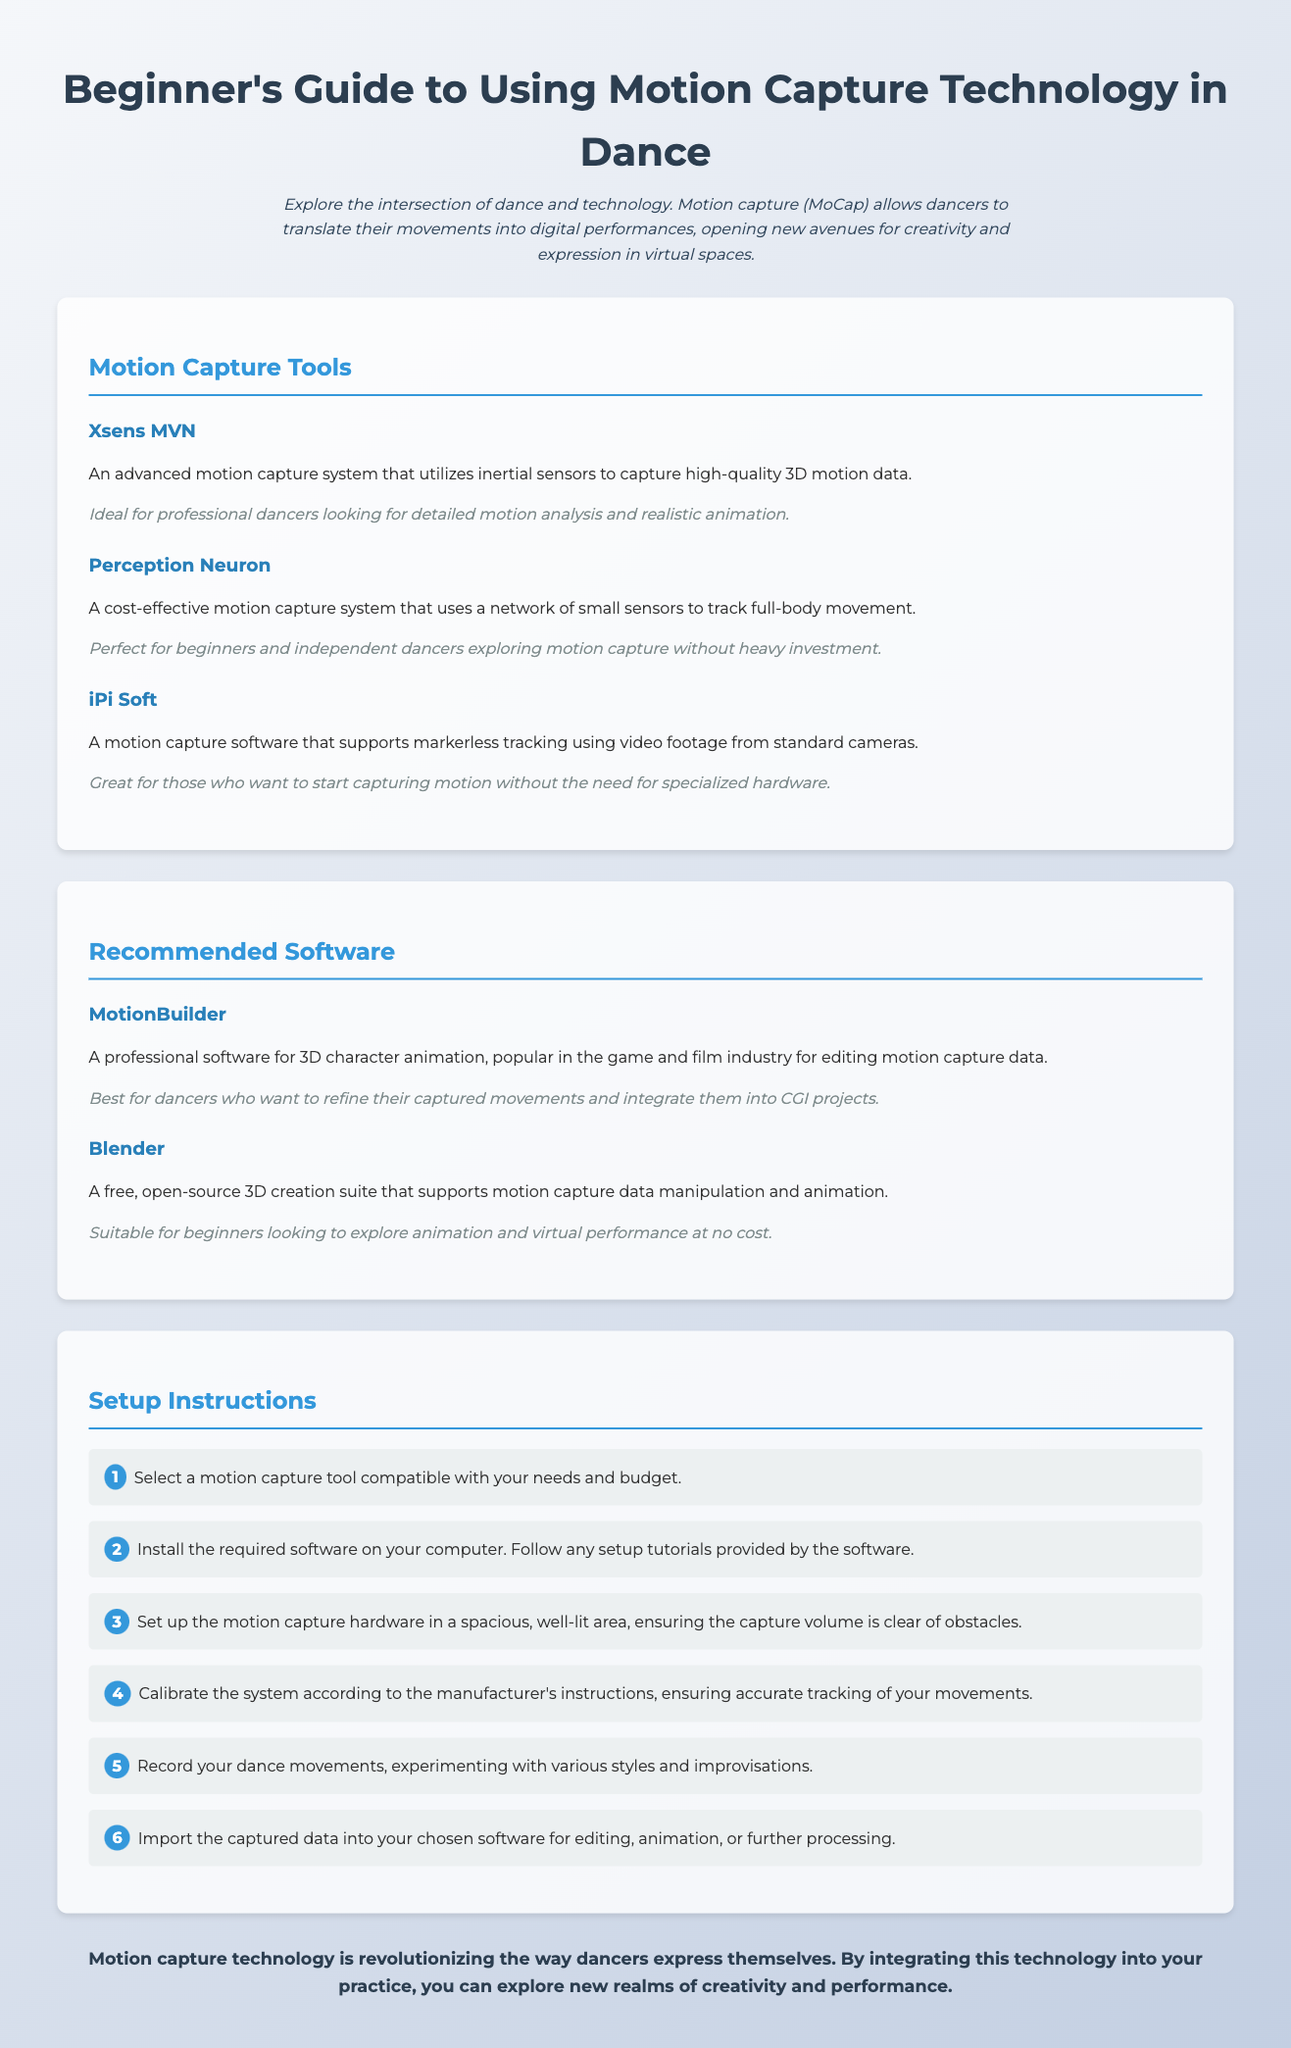what is the purpose of motion capture technology in dance? Motion capture allows dancers to translate their movements into digital performances, opening new avenues for creativity and expression in virtual spaces.
Answer: digital performances what is one recommended motion capture tool for beginners? The document provides multiple motion capture tools. One option mentioned for beginners is the Perception Neuron.
Answer: Perception Neuron how many steps are in the setup instructions? The setup instructions are outlined in an ordered list, which consists of six steps.
Answer: six which software is best for refining captured movements? The recommended software that is best for refining captured movements is MotionBuilder.
Answer: MotionBuilder what is iPi Soft primarily used for? iPi Soft is primarily used for markerless tracking using video footage from standard cameras.
Answer: markerless tracking 